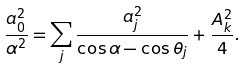Convert formula to latex. <formula><loc_0><loc_0><loc_500><loc_500>\frac { a _ { 0 } ^ { 2 } } { \alpha ^ { 2 } } = \sum _ { j } \frac { a _ { j } ^ { 2 } } { \cos \alpha - \cos \theta _ { j } } + \frac { A _ { k } ^ { 2 } } { 4 } .</formula> 